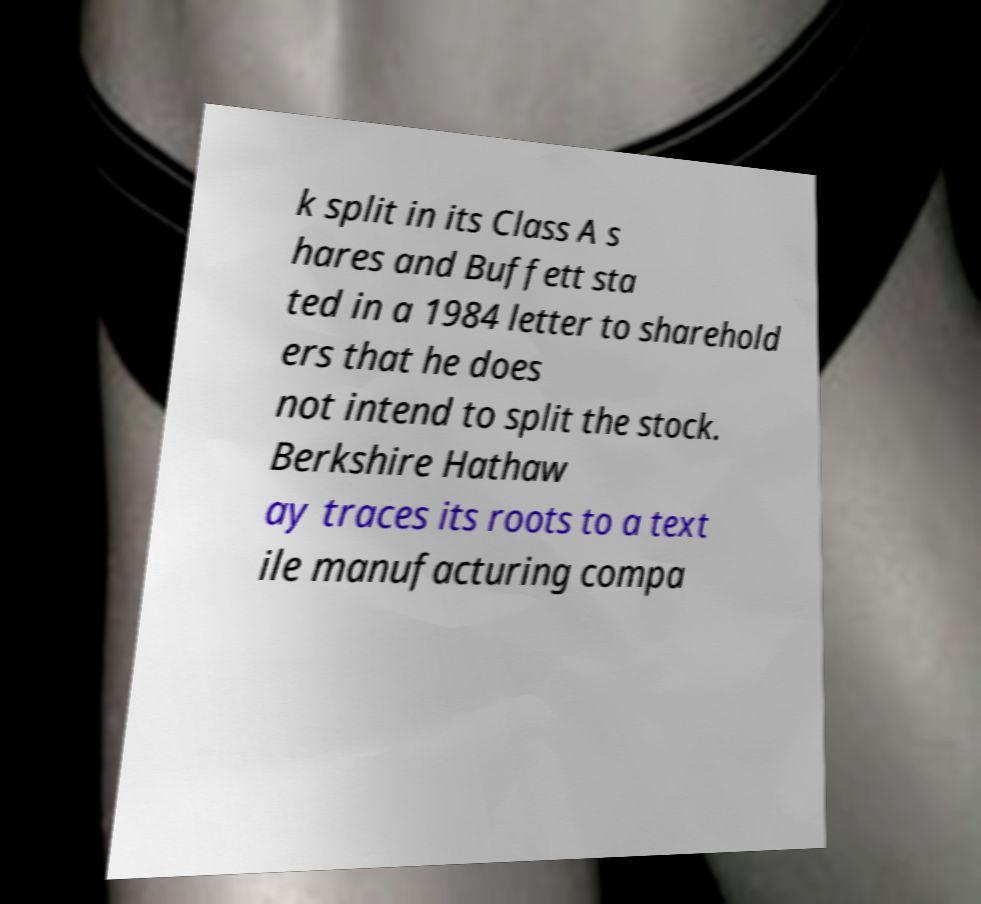I need the written content from this picture converted into text. Can you do that? k split in its Class A s hares and Buffett sta ted in a 1984 letter to sharehold ers that he does not intend to split the stock. Berkshire Hathaw ay traces its roots to a text ile manufacturing compa 